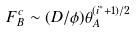Convert formula to latex. <formula><loc_0><loc_0><loc_500><loc_500>F _ { B } ^ { c } \sim ( D / \phi ) \theta _ { A } ^ { ( i ^ { \ast } + 1 ) / 2 }</formula> 